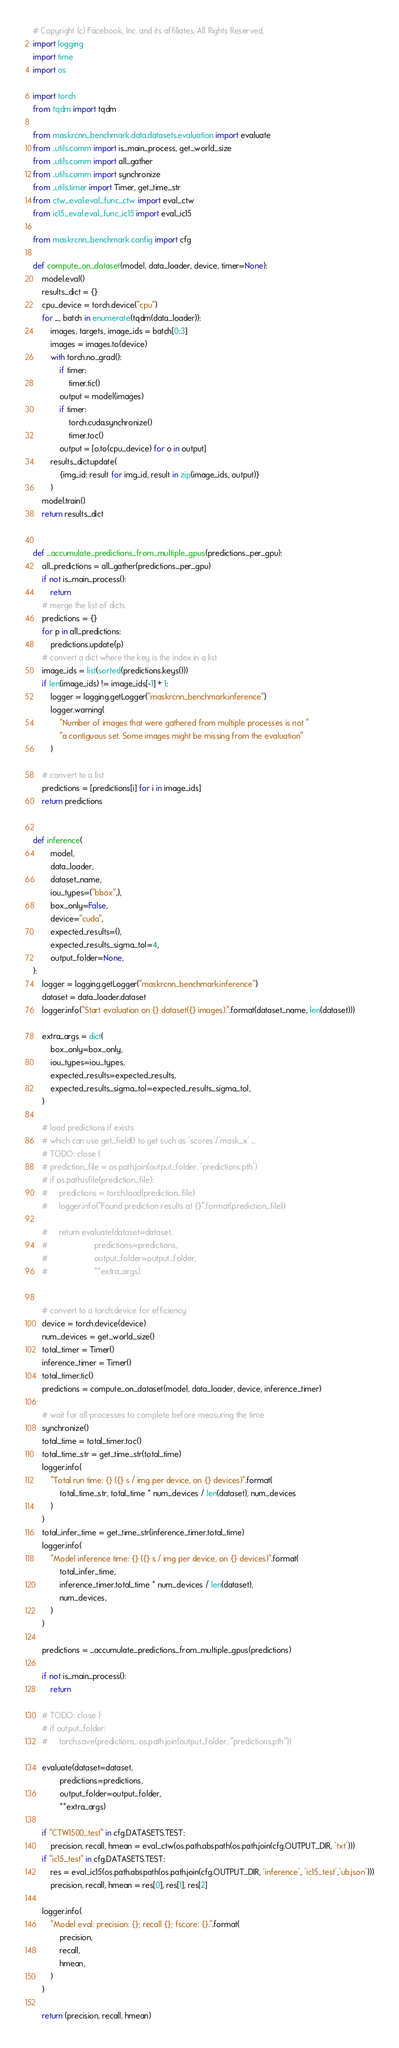<code> <loc_0><loc_0><loc_500><loc_500><_Python_># Copyright (c) Facebook, Inc. and its affiliates. All Rights Reserved.
import logging
import time
import os

import torch
from tqdm import tqdm

from maskrcnn_benchmark.data.datasets.evaluation import evaluate
from ..utils.comm import is_main_process, get_world_size
from ..utils.comm import all_gather
from ..utils.comm import synchronize
from ..utils.timer import Timer, get_time_str
from ctw_eval.eval_func_ctw import eval_ctw
from ic15_eval.eval_func_ic15 import eval_ic15

from maskrcnn_benchmark.config import cfg

def compute_on_dataset(model, data_loader, device, timer=None):
    model.eval()
    results_dict = {}
    cpu_device = torch.device("cpu")
    for _, batch in enumerate(tqdm(data_loader)):
        images, targets, image_ids = batch[0:3]
        images = images.to(device)
        with torch.no_grad():
            if timer:
                timer.tic()
            output = model(images)
            if timer:
                torch.cuda.synchronize()
                timer.toc()
            output = [o.to(cpu_device) for o in output]
        results_dict.update(
            {img_id: result for img_id, result in zip(image_ids, output)}
        )
    model.train()
    return results_dict


def _accumulate_predictions_from_multiple_gpus(predictions_per_gpu):
    all_predictions = all_gather(predictions_per_gpu)
    if not is_main_process():
        return
    # merge the list of dicts
    predictions = {}
    for p in all_predictions:
        predictions.update(p)
    # convert a dict where the key is the index in a list
    image_ids = list(sorted(predictions.keys()))
    if len(image_ids) != image_ids[-1] + 1:
        logger = logging.getLogger("maskrcnn_benchmark.inference")
        logger.warning(
            "Number of images that were gathered from multiple processes is not "
            "a contiguous set. Some images might be missing from the evaluation"
        )

    # convert to a list
    predictions = [predictions[i] for i in image_ids]
    return predictions


def inference(
        model,
        data_loader,
        dataset_name,
        iou_types=("bbox",),
        box_only=False,
        device="cuda",
        expected_results=(),
        expected_results_sigma_tol=4,
        output_folder=None,
):
    logger = logging.getLogger("maskrcnn_benchmark.inference")
    dataset = data_loader.dataset
    logger.info("Start evaluation on {} dataset({} images).".format(dataset_name, len(dataset)))

    extra_args = dict(
        box_only=box_only,
        iou_types=iou_types,
        expected_results=expected_results,
        expected_results_sigma_tol=expected_results_sigma_tol,
    )

    # load predictions if exists
    # which can use get_field() to get such as 'scores'/'mask_x' ...
    # TODO: close (
    # prediction_file = os.path.join(output_folder, 'predictions.pth')
    # if os.path.isfile(prediction_file):
    #     predictions = torch.load(prediction_file)
    #     logger.info("Found prediction results at {}".format(prediction_file))

    #     return evaluate(dataset=dataset,
    #                     predictions=predictions,
    #                     output_folder=output_folder,
    #                     **extra_args)
    

    # convert to a torch.device for efficiency
    device = torch.device(device)
    num_devices = get_world_size()
    total_timer = Timer()
    inference_timer = Timer()
    total_timer.tic()
    predictions = compute_on_dataset(model, data_loader, device, inference_timer)

    # wait for all processes to complete before measuring the time
    synchronize()
    total_time = total_timer.toc()
    total_time_str = get_time_str(total_time)
    logger.info(
        "Total run time: {} ({} s / img per device, on {} devices)".format(
            total_time_str, total_time * num_devices / len(dataset), num_devices
        )
    )
    total_infer_time = get_time_str(inference_timer.total_time)
    logger.info(
        "Model inference time: {} ({} s / img per device, on {} devices)".format(
            total_infer_time,
            inference_timer.total_time * num_devices / len(dataset),
            num_devices,
        )
    )

    predictions = _accumulate_predictions_from_multiple_gpus(predictions)
    
    if not is_main_process():
        return

    # TODO: close )
    # if output_folder:
    #     torch.save(predictions, os.path.join(output_folder, "predictions.pth"))

    evaluate(dataset=dataset,
            predictions=predictions,
            output_folder=output_folder,
            **extra_args)
    
    if "CTW1500_test" in cfg.DATASETS.TEST:
        precision, recall, hmean = eval_ctw(os.path.abspath(os.path.join(cfg.OUTPUT_DIR, 'txt')))
    if "ic15_test" in cfg.DATASETS.TEST:
        res = eval_ic15(os.path.abspath(os.path.join(cfg.OUTPUT_DIR, 'inference', 'ic15_test','ub.json')))
        precision, recall, hmean = res[0], res[1], res[2]

    logger.info(
        "Model eval: precision: {}; recall {}; fscore: {}.".format(
            precision,
            recall,
            hmean,
        )
    )

    return (precision, recall, hmean)
</code> 